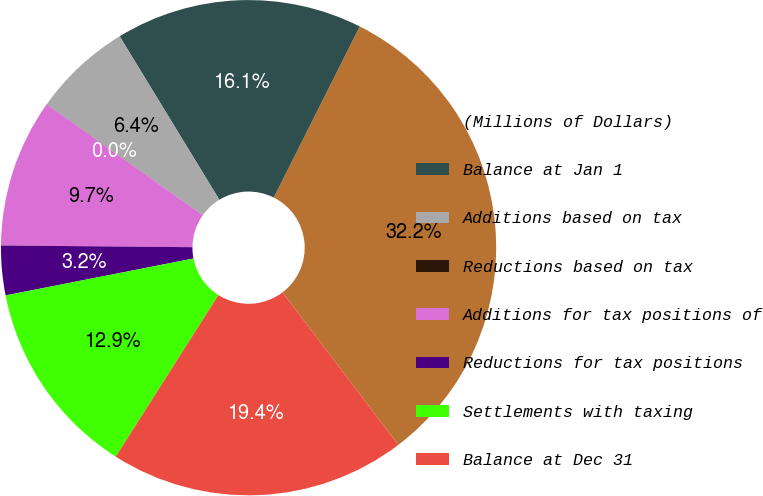Convert chart. <chart><loc_0><loc_0><loc_500><loc_500><pie_chart><fcel>(Millions of Dollars)<fcel>Balance at Jan 1<fcel>Additions based on tax<fcel>Reductions based on tax<fcel>Additions for tax positions of<fcel>Reductions for tax positions<fcel>Settlements with taxing<fcel>Balance at Dec 31<nl><fcel>32.25%<fcel>16.13%<fcel>6.45%<fcel>0.01%<fcel>9.68%<fcel>3.23%<fcel>12.9%<fcel>19.35%<nl></chart> 